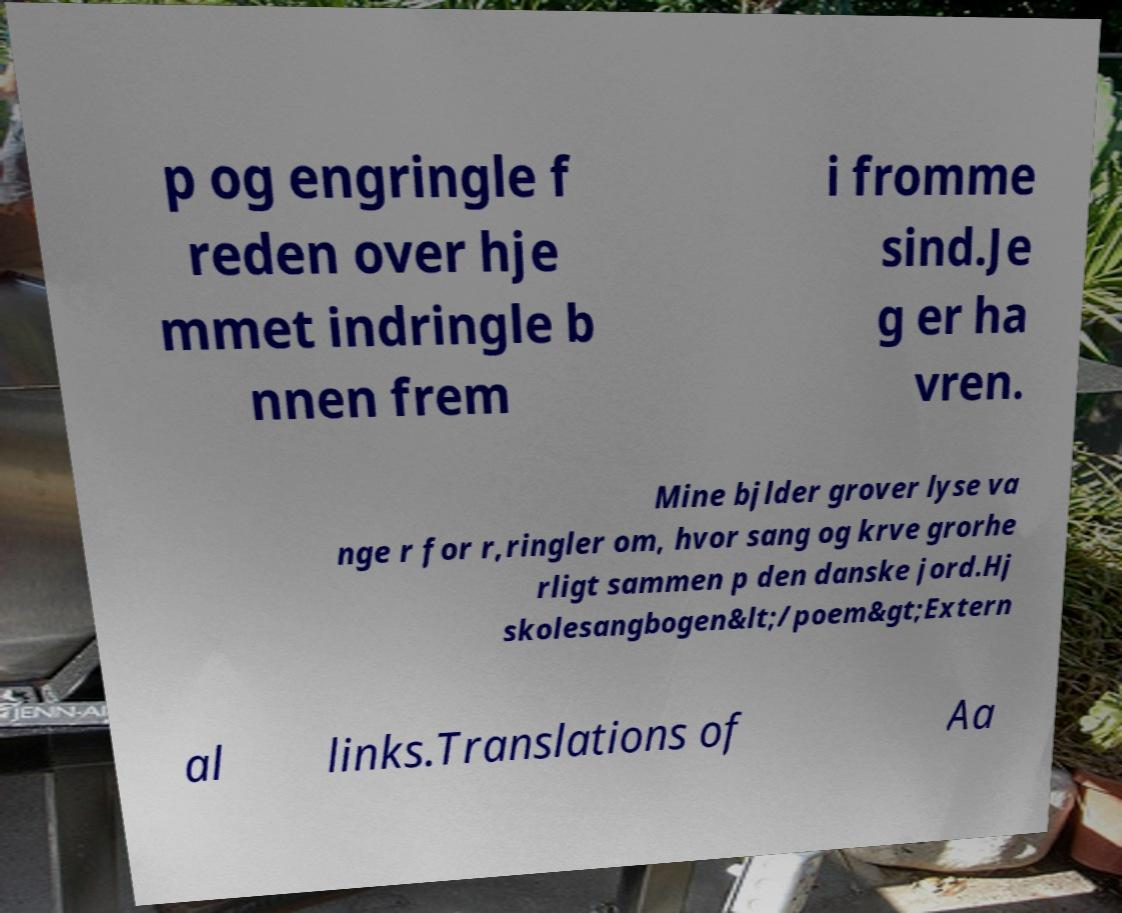Could you assist in decoding the text presented in this image and type it out clearly? p og engringle f reden over hje mmet indringle b nnen frem i fromme sind.Je g er ha vren. Mine bjlder grover lyse va nge r for r,ringler om, hvor sang og krve grorhe rligt sammen p den danske jord.Hj skolesangbogen&lt;/poem&gt;Extern al links.Translations of Aa 